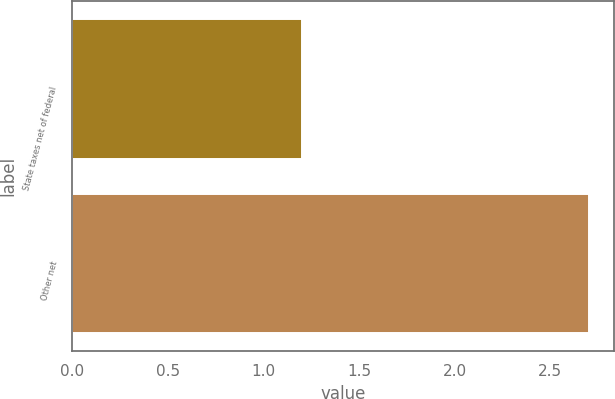Convert chart. <chart><loc_0><loc_0><loc_500><loc_500><bar_chart><fcel>State taxes net of federal<fcel>Other net<nl><fcel>1.2<fcel>2.7<nl></chart> 